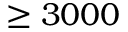<formula> <loc_0><loc_0><loc_500><loc_500>\geq 3 0 0 0</formula> 